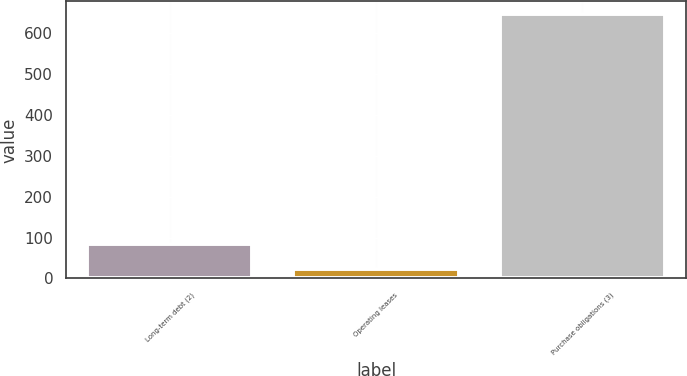<chart> <loc_0><loc_0><loc_500><loc_500><bar_chart><fcel>Long-term debt (2)<fcel>Operating leases<fcel>Purchase obligations (3)<nl><fcel>85.3<fcel>23<fcel>646<nl></chart> 